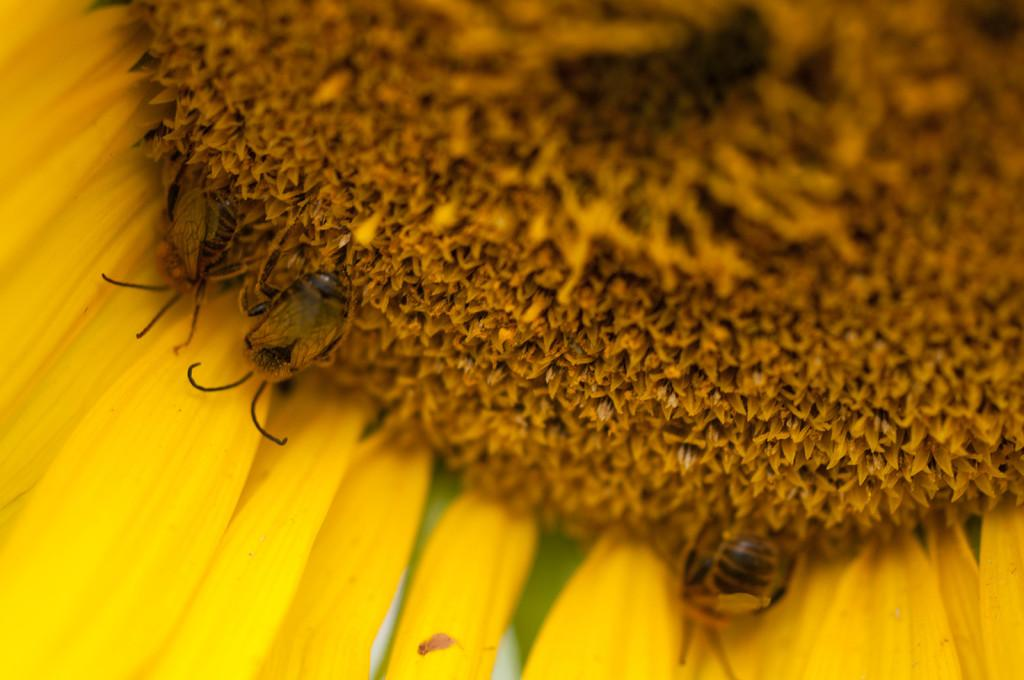What type of insects can be seen in the image? There are bees in the image. What are the bees doing in the image? The bees are on a sunflower. How many kittens can be seen playing around the sunflower in the image? There are no kittens present in the image; it features bees on a sunflower. What type of structure is visible in the background of the image? There is no structure visible in the background of the image; it only shows bees on a sunflower. 